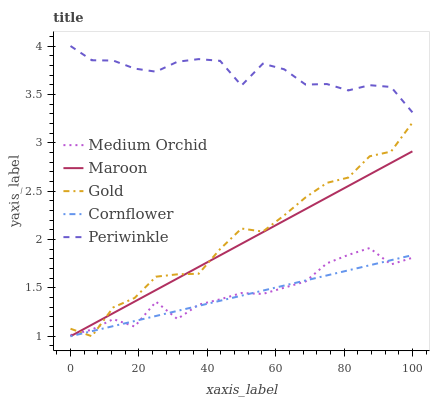Does Cornflower have the minimum area under the curve?
Answer yes or no. Yes. Does Periwinkle have the maximum area under the curve?
Answer yes or no. Yes. Does Medium Orchid have the minimum area under the curve?
Answer yes or no. No. Does Medium Orchid have the maximum area under the curve?
Answer yes or no. No. Is Cornflower the smoothest?
Answer yes or no. Yes. Is Gold the roughest?
Answer yes or no. Yes. Is Medium Orchid the smoothest?
Answer yes or no. No. Is Medium Orchid the roughest?
Answer yes or no. No. Does Cornflower have the lowest value?
Answer yes or no. Yes. Does Medium Orchid have the lowest value?
Answer yes or no. No. Does Periwinkle have the highest value?
Answer yes or no. Yes. Does Medium Orchid have the highest value?
Answer yes or no. No. Is Cornflower less than Periwinkle?
Answer yes or no. Yes. Is Periwinkle greater than Medium Orchid?
Answer yes or no. Yes. Does Cornflower intersect Gold?
Answer yes or no. Yes. Is Cornflower less than Gold?
Answer yes or no. No. Is Cornflower greater than Gold?
Answer yes or no. No. Does Cornflower intersect Periwinkle?
Answer yes or no. No. 